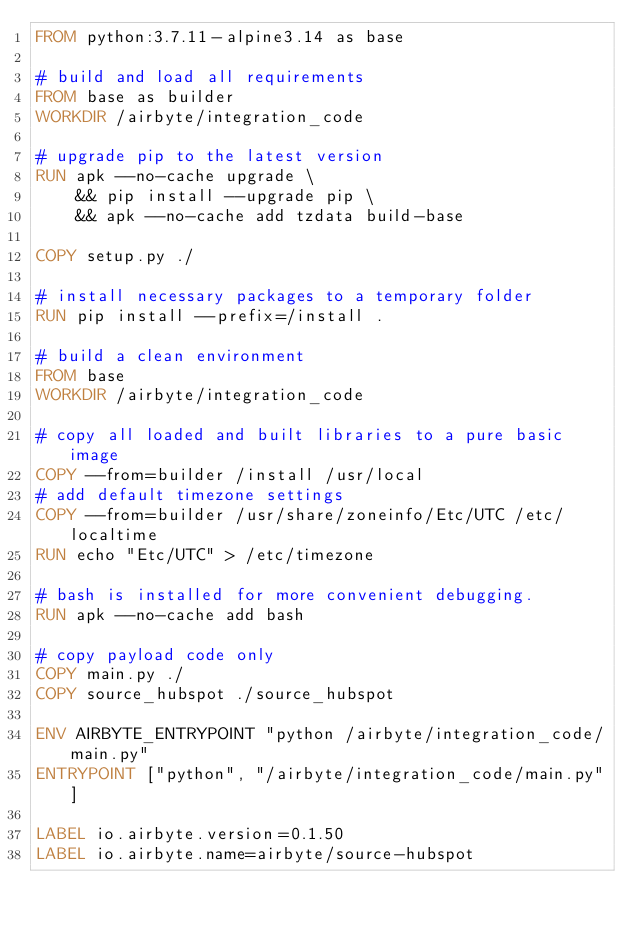<code> <loc_0><loc_0><loc_500><loc_500><_Dockerfile_>FROM python:3.7.11-alpine3.14 as base

# build and load all requirements
FROM base as builder
WORKDIR /airbyte/integration_code

# upgrade pip to the latest version
RUN apk --no-cache upgrade \
    && pip install --upgrade pip \
    && apk --no-cache add tzdata build-base

COPY setup.py ./

# install necessary packages to a temporary folder
RUN pip install --prefix=/install .

# build a clean environment
FROM base
WORKDIR /airbyte/integration_code

# copy all loaded and built libraries to a pure basic image
COPY --from=builder /install /usr/local
# add default timezone settings
COPY --from=builder /usr/share/zoneinfo/Etc/UTC /etc/localtime
RUN echo "Etc/UTC" > /etc/timezone

# bash is installed for more convenient debugging.
RUN apk --no-cache add bash

# copy payload code only
COPY main.py ./
COPY source_hubspot ./source_hubspot

ENV AIRBYTE_ENTRYPOINT "python /airbyte/integration_code/main.py"
ENTRYPOINT ["python", "/airbyte/integration_code/main.py"]

LABEL io.airbyte.version=0.1.50
LABEL io.airbyte.name=airbyte/source-hubspot
</code> 